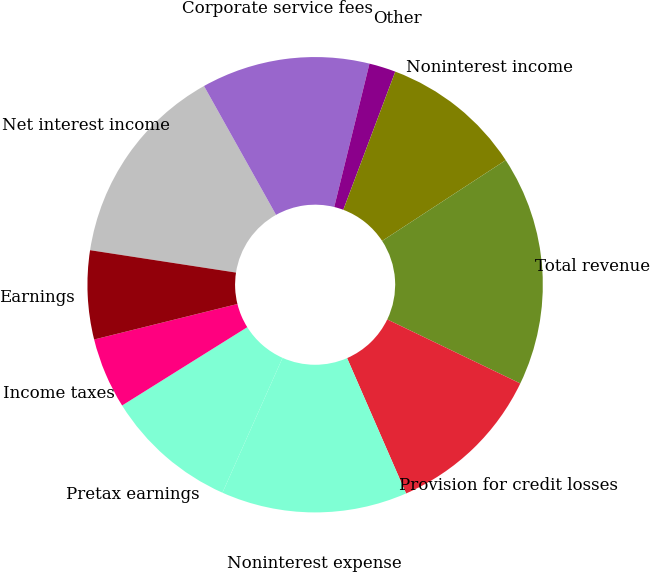Convert chart. <chart><loc_0><loc_0><loc_500><loc_500><pie_chart><fcel>Net interest income<fcel>Corporate service fees<fcel>Other<fcel>Noninterest income<fcel>Total revenue<fcel>Provision for credit losses<fcel>Noninterest expense<fcel>Pretax earnings<fcel>Income taxes<fcel>Earnings<nl><fcel>14.46%<fcel>11.95%<fcel>1.89%<fcel>10.06%<fcel>16.35%<fcel>11.32%<fcel>13.21%<fcel>9.43%<fcel>5.03%<fcel>6.29%<nl></chart> 